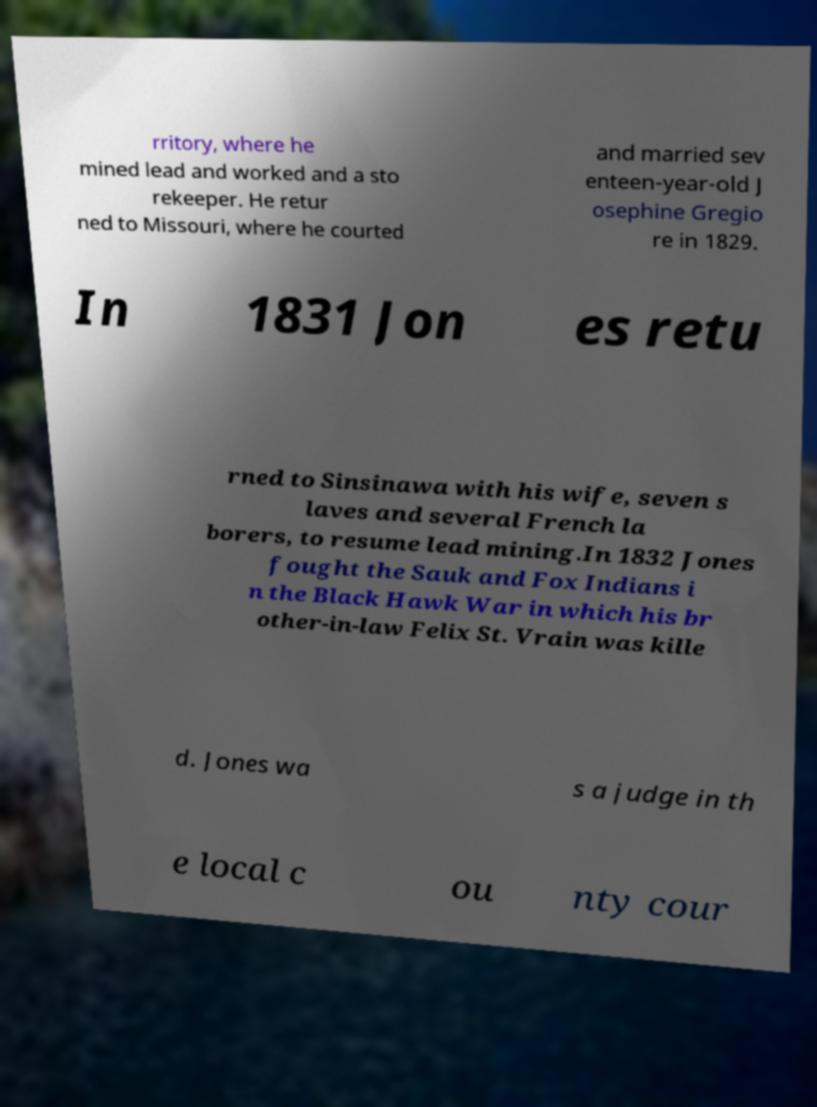I need the written content from this picture converted into text. Can you do that? rritory, where he mined lead and worked and a sto rekeeper. He retur ned to Missouri, where he courted and married sev enteen-year-old J osephine Gregio re in 1829. In 1831 Jon es retu rned to Sinsinawa with his wife, seven s laves and several French la borers, to resume lead mining.In 1832 Jones fought the Sauk and Fox Indians i n the Black Hawk War in which his br other-in-law Felix St. Vrain was kille d. Jones wa s a judge in th e local c ou nty cour 